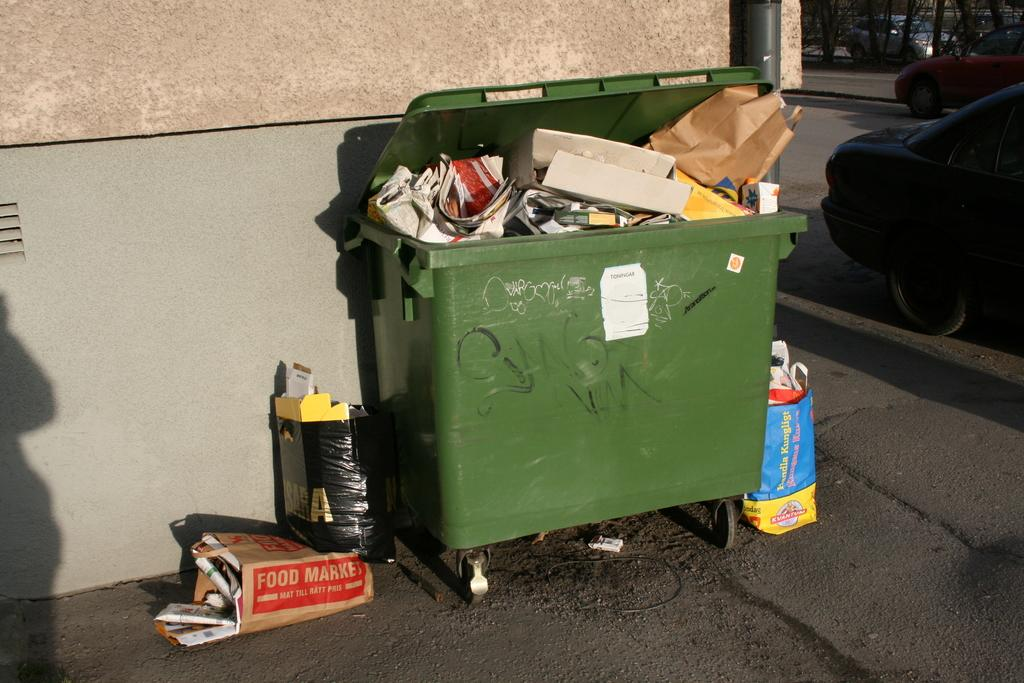<image>
Describe the image concisely. A paper bag from Food Market is sitting next to a green dumpster. 